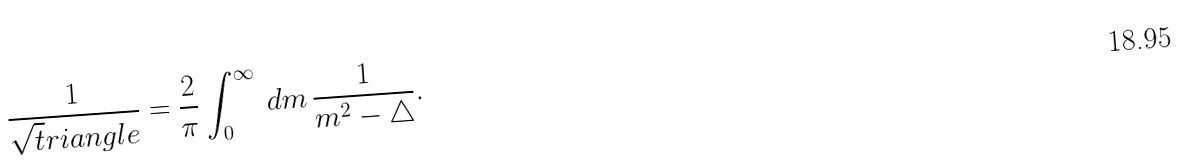Convert formula to latex. <formula><loc_0><loc_0><loc_500><loc_500>\frac { 1 } { \sqrt { t } r i a n g l e } = \frac { 2 } { \pi } \int _ { 0 } ^ { \infty } \, { d } m \, \frac { 1 } { m ^ { 2 } - \triangle } .</formula> 